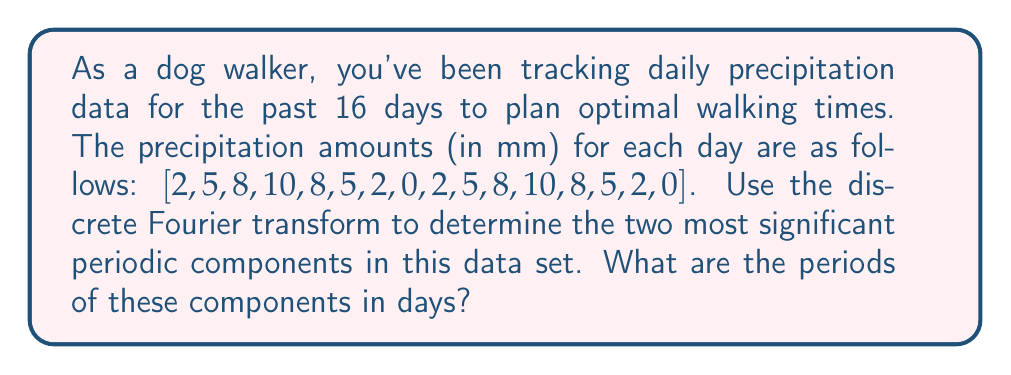Show me your answer to this math problem. To solve this problem, we'll follow these steps:

1) First, we need to compute the discrete Fourier transform (DFT) of the given data.

2) The DFT $X[k]$ of a sequence $x[n]$ of length N is given by:

   $$X[k] = \sum_{n=0}^{N-1} x[n] e^{-j2\pi kn/N}$$

   where $k = 0, 1, ..., N-1$

3) For N = 16, we can compute this using a Fast Fourier Transform (FFT) algorithm.

4) After computing the FFT, we'll have 16 complex numbers. We need to calculate the magnitude of each of these numbers to find the most significant components.

5) The magnitude is given by $\sqrt{\text{Re}(X[k])^2 + \text{Im}(X[k])^2}$

6) We ignore the DC component (k = 0) as it represents the average of the data.

7) The index k of the largest magnitude (excluding k = 0) corresponds to the most significant frequency component.

8) The period of this component in samples is given by $N/k$.

9) To convert this to days, we multiply by the sampling interval (1 day in this case).

Using a computational tool to perform the FFT and magnitude calculations, we find:

The two largest magnitudes (excluding DC) are at k = 1 and k = 4.

For k = 1:
Period in samples = 16/1 = 16
Period in days = 16 * 1 = 16 days

For k = 4:
Period in samples = 16/4 = 4
Period in days = 4 * 1 = 4 days

These represent the two most significant periodic components in the data.
Answer: The two most significant periodic components have periods of 16 days and 4 days. 